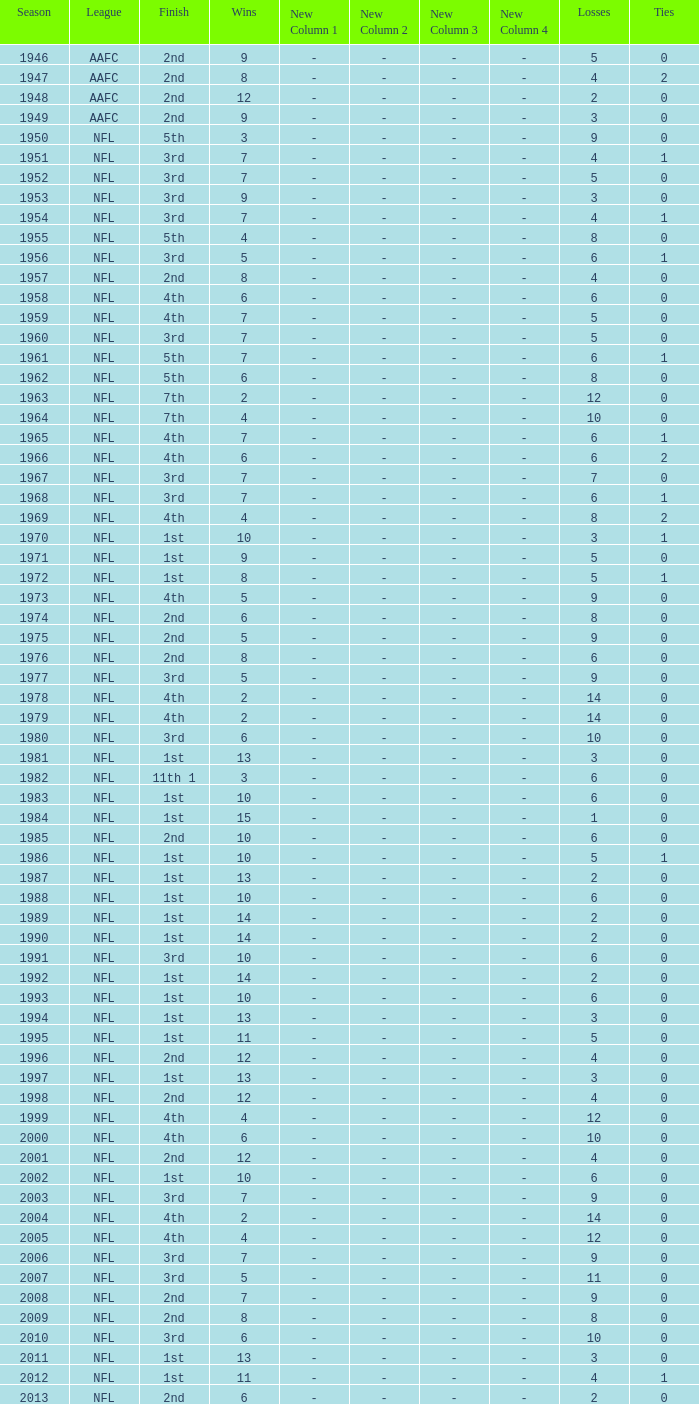What is the lowest number of ties in the NFL, with less than 2 losses and less than 15 wins? None. 